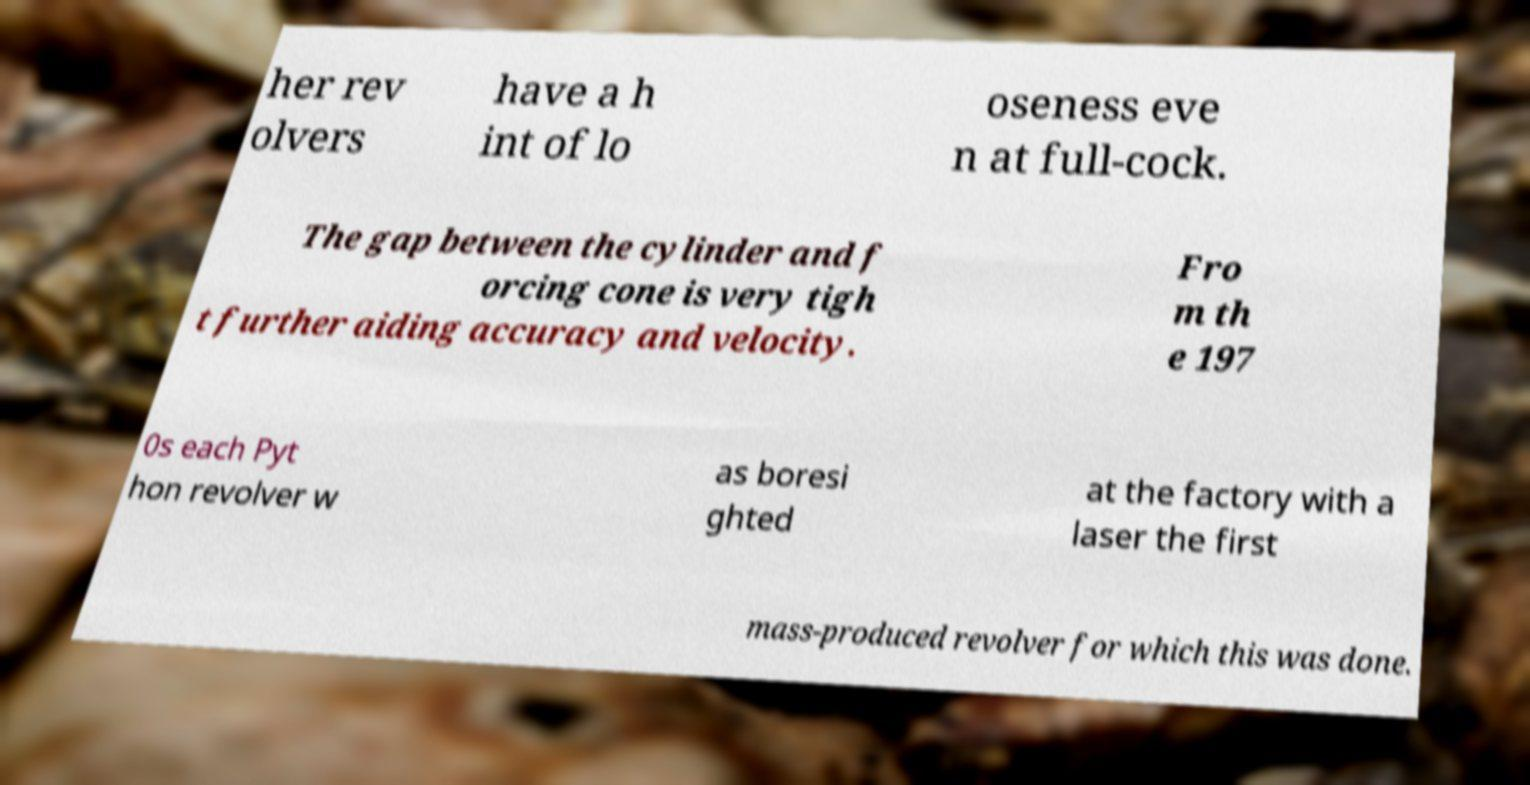Could you assist in decoding the text presented in this image and type it out clearly? her rev olvers have a h int of lo oseness eve n at full-cock. The gap between the cylinder and f orcing cone is very tigh t further aiding accuracy and velocity. Fro m th e 197 0s each Pyt hon revolver w as boresi ghted at the factory with a laser the first mass-produced revolver for which this was done. 